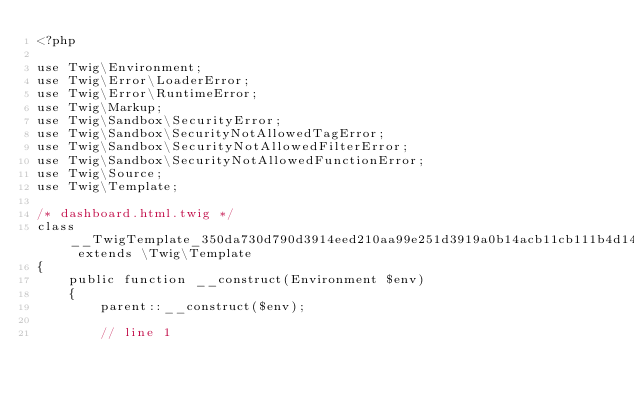Convert code to text. <code><loc_0><loc_0><loc_500><loc_500><_PHP_><?php

use Twig\Environment;
use Twig\Error\LoaderError;
use Twig\Error\RuntimeError;
use Twig\Markup;
use Twig\Sandbox\SecurityError;
use Twig\Sandbox\SecurityNotAllowedTagError;
use Twig\Sandbox\SecurityNotAllowedFilterError;
use Twig\Sandbox\SecurityNotAllowedFunctionError;
use Twig\Source;
use Twig\Template;

/* dashboard.html.twig */
class __TwigTemplate_350da730d790d3914eed210aa99e251d3919a0b14acb11cb111b4d14ea52fd94 extends \Twig\Template
{
    public function __construct(Environment $env)
    {
        parent::__construct($env);

        // line 1</code> 